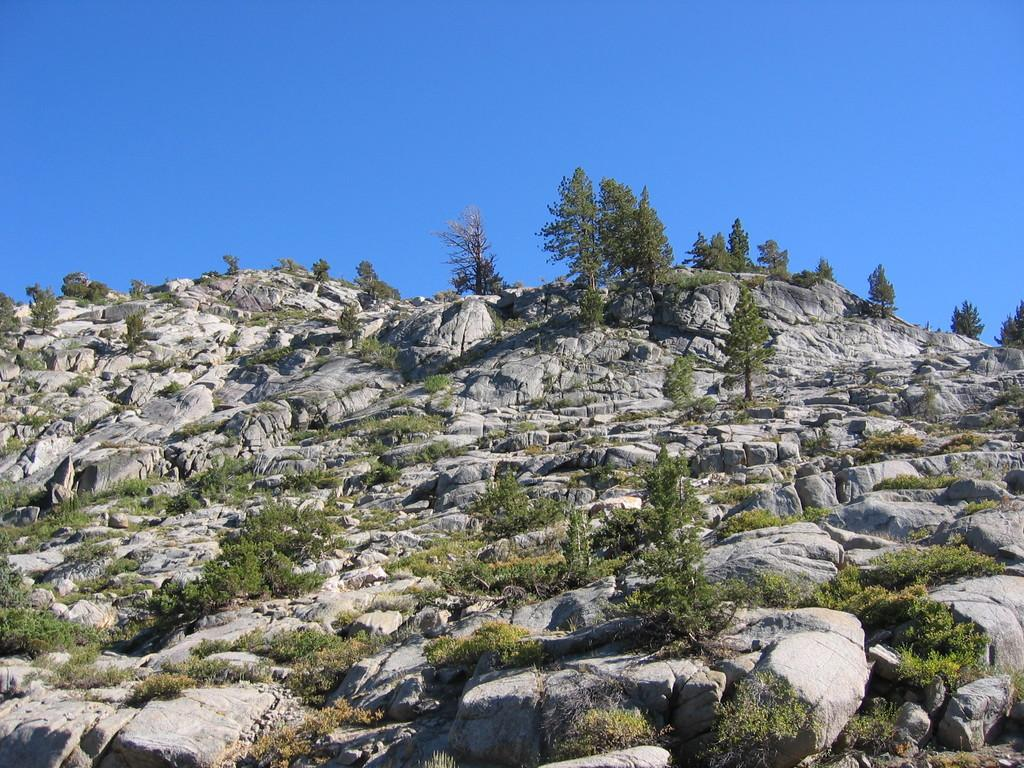What is the main subject of the picture? The main subject of the picture is a mountain. What types of vegetation can be seen on the mountain? The mountain has plants, rocks, and trees. What is the condition of the sky in the picture? The sky is clear in the picture. Can you see a chain made of flesh on the mountain in the image? There is no chain made of flesh present on the mountain in the image. What type of play is happening on the mountain in the image? There is no play or any indication of play happening on the mountain in the image. 